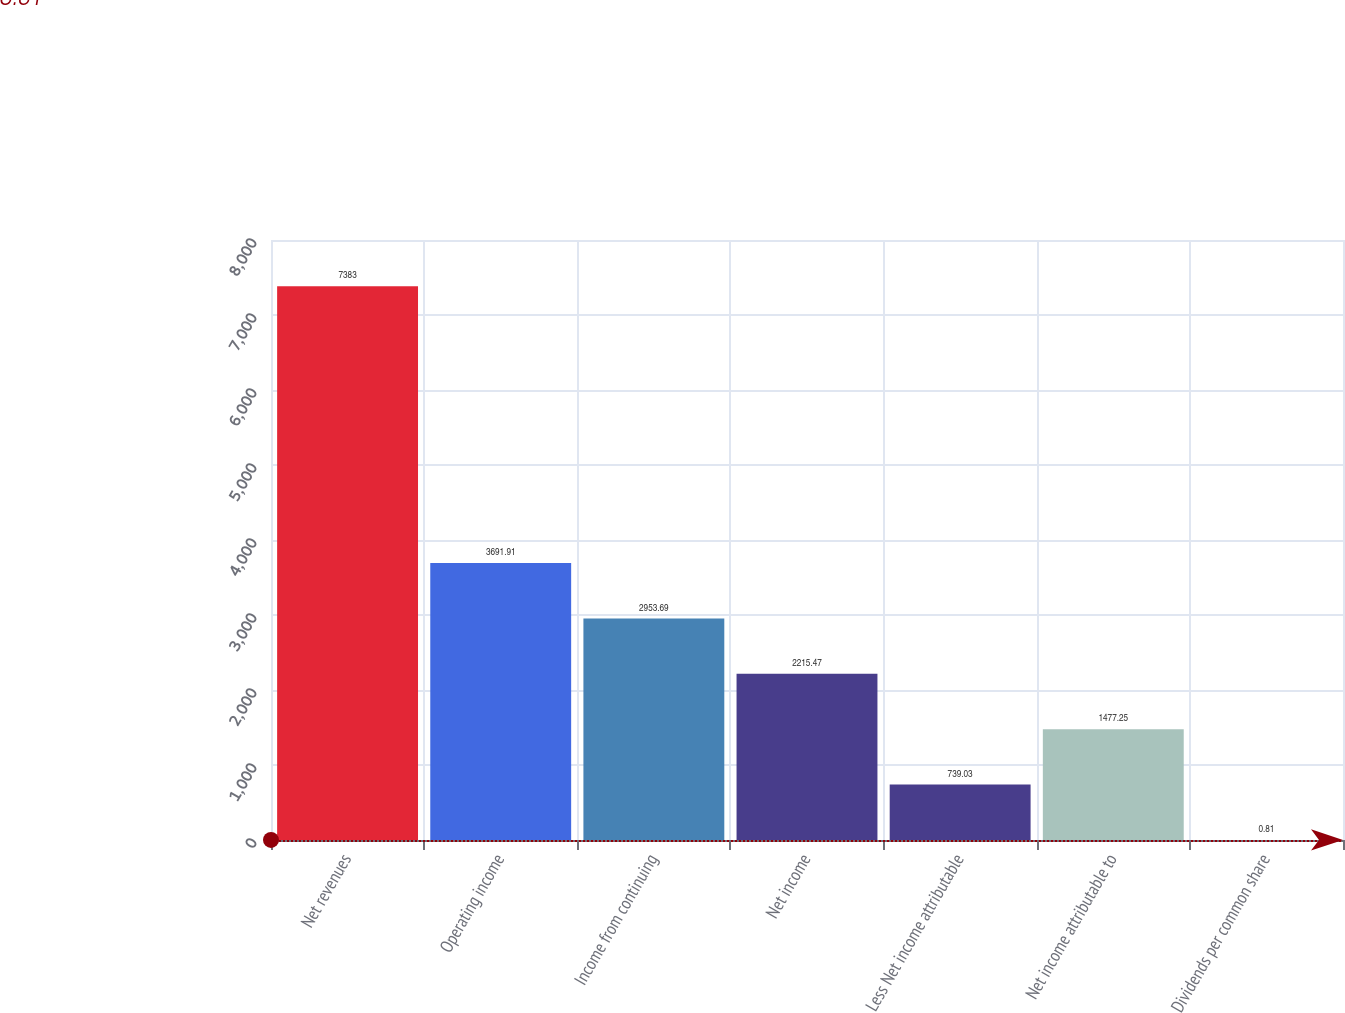Convert chart. <chart><loc_0><loc_0><loc_500><loc_500><bar_chart><fcel>Net revenues<fcel>Operating income<fcel>Income from continuing<fcel>Net income<fcel>Less Net income attributable<fcel>Net income attributable to<fcel>Dividends per common share<nl><fcel>7383<fcel>3691.91<fcel>2953.69<fcel>2215.47<fcel>739.03<fcel>1477.25<fcel>0.81<nl></chart> 